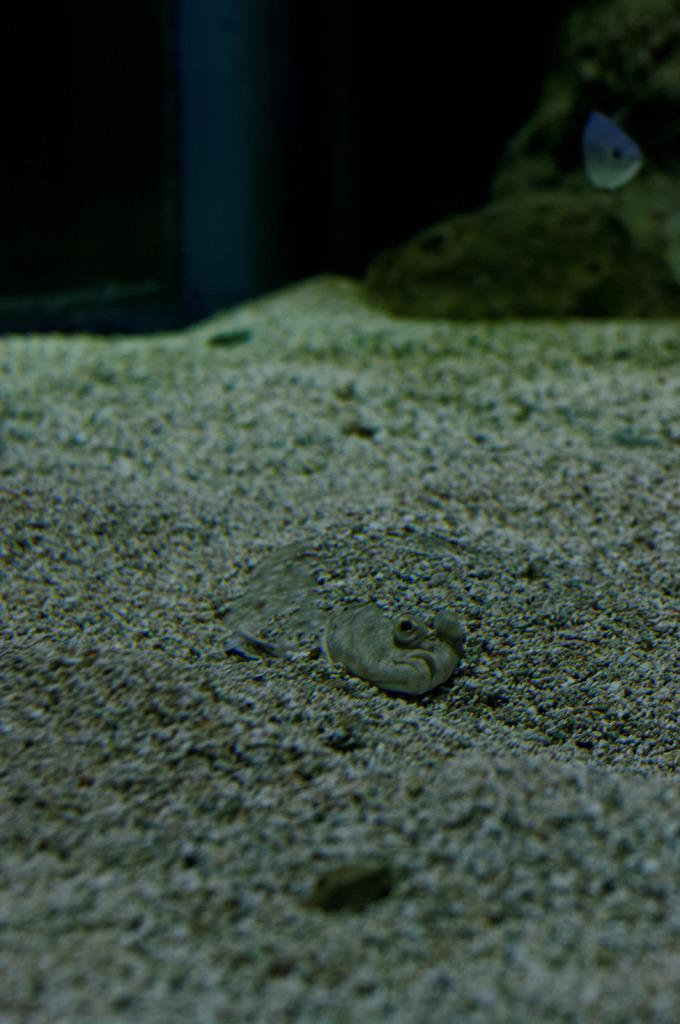In one or two sentences, can you explain what this image depicts? In this picture I can observe sand. In the middle of the picture there is a reptile which is looking like snake. The background is blurred. 